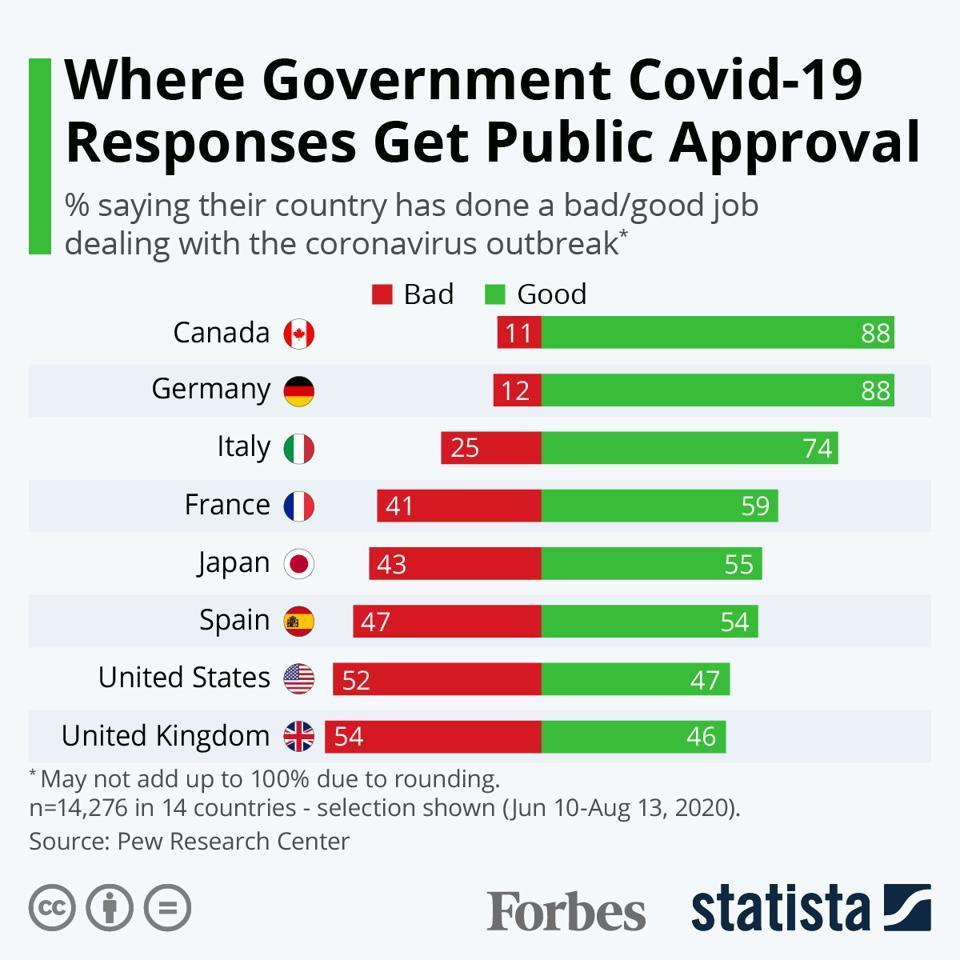Give some essential details in this illustration. The majority of the people of France have a positive opinion of the government's handling of the COVID-19 outbreak, viewing it as good. The governments of Canada, Germany, and Italy have received over 70% positive responses from the public. The government of Canada and Germany have received the highest percentage of positive responses from the public. According to a recent survey, 54% of the people in Spain have expressed a positive response towards the government's handling of the COVID-19 outbreak. Eight countries are listed in this data visualization. 